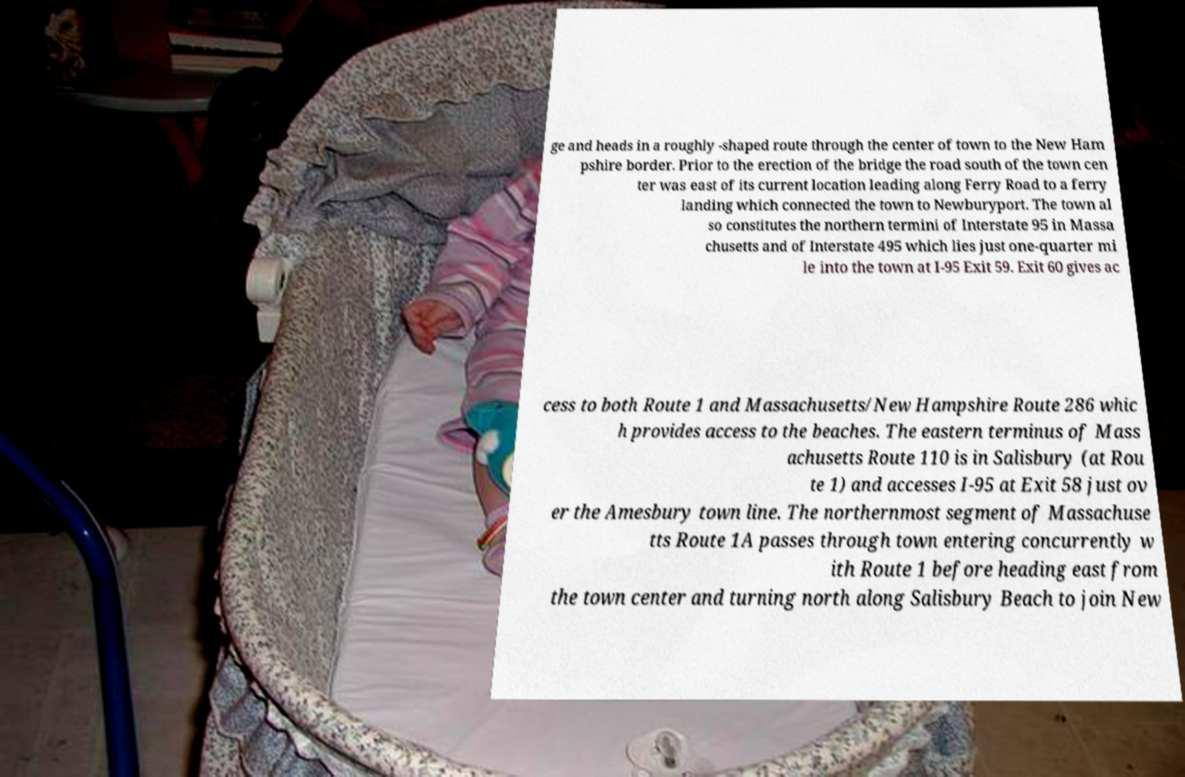Please read and relay the text visible in this image. What does it say? ge and heads in a roughly -shaped route through the center of town to the New Ham pshire border. Prior to the erection of the bridge the road south of the town cen ter was east of its current location leading along Ferry Road to a ferry landing which connected the town to Newburyport. The town al so constitutes the northern termini of Interstate 95 in Massa chusetts and of Interstate 495 which lies just one-quarter mi le into the town at I-95 Exit 59. Exit 60 gives ac cess to both Route 1 and Massachusetts/New Hampshire Route 286 whic h provides access to the beaches. The eastern terminus of Mass achusetts Route 110 is in Salisbury (at Rou te 1) and accesses I-95 at Exit 58 just ov er the Amesbury town line. The northernmost segment of Massachuse tts Route 1A passes through town entering concurrently w ith Route 1 before heading east from the town center and turning north along Salisbury Beach to join New 